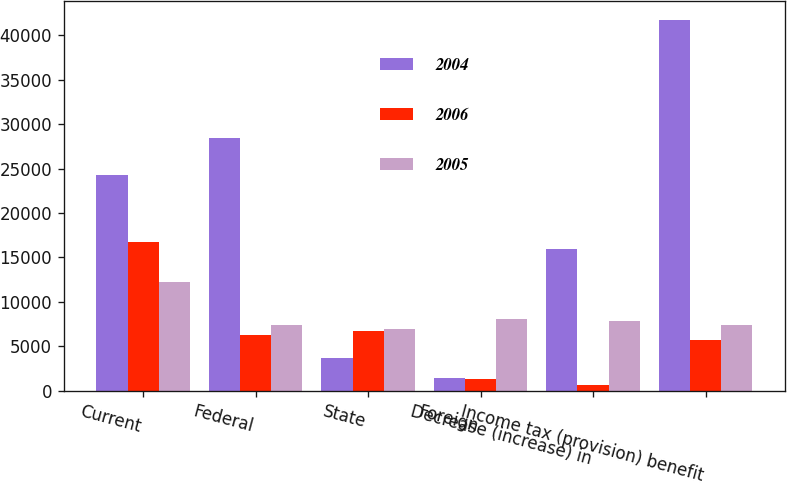Convert chart to OTSL. <chart><loc_0><loc_0><loc_500><loc_500><stacked_bar_chart><ecel><fcel>Current<fcel>Federal<fcel>State<fcel>Foreign<fcel>Decrease (increase) in<fcel>Income tax (provision) benefit<nl><fcel>2004<fcel>24233<fcel>28488<fcel>3647<fcel>1389<fcel>15989<fcel>41768<nl><fcel>2006<fcel>16755<fcel>6230<fcel>6783<fcel>1342<fcel>630<fcel>5714<nl><fcel>2005<fcel>12267<fcel>7392.5<fcel>6937<fcel>8110<fcel>7848<fcel>7392.5<nl></chart> 